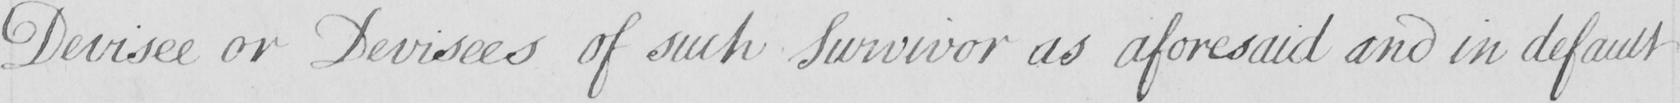Transcribe the text shown in this historical manuscript line. Devisee or Devisees of such Survivor as aforesaid and in default 